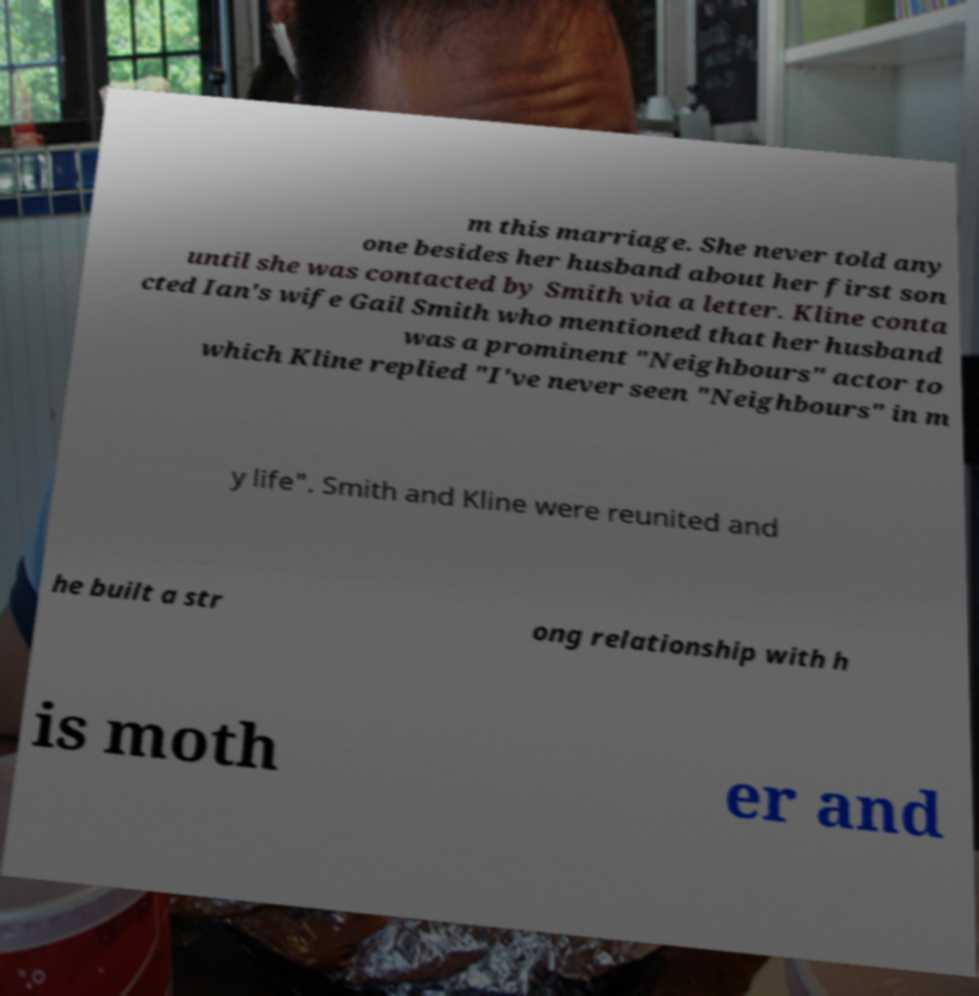Please identify and transcribe the text found in this image. m this marriage. She never told any one besides her husband about her first son until she was contacted by Smith via a letter. Kline conta cted Ian's wife Gail Smith who mentioned that her husband was a prominent "Neighbours" actor to which Kline replied "I've never seen "Neighbours" in m y life". Smith and Kline were reunited and he built a str ong relationship with h is moth er and 